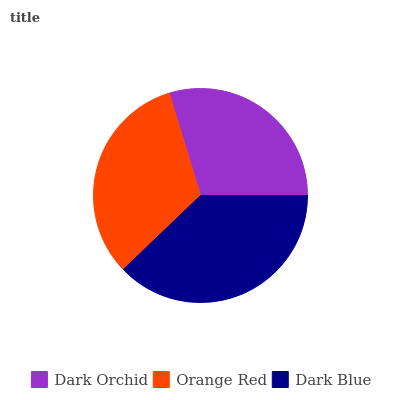Is Dark Orchid the minimum?
Answer yes or no. Yes. Is Dark Blue the maximum?
Answer yes or no. Yes. Is Orange Red the minimum?
Answer yes or no. No. Is Orange Red the maximum?
Answer yes or no. No. Is Orange Red greater than Dark Orchid?
Answer yes or no. Yes. Is Dark Orchid less than Orange Red?
Answer yes or no. Yes. Is Dark Orchid greater than Orange Red?
Answer yes or no. No. Is Orange Red less than Dark Orchid?
Answer yes or no. No. Is Orange Red the high median?
Answer yes or no. Yes. Is Orange Red the low median?
Answer yes or no. Yes. Is Dark Blue the high median?
Answer yes or no. No. Is Dark Orchid the low median?
Answer yes or no. No. 